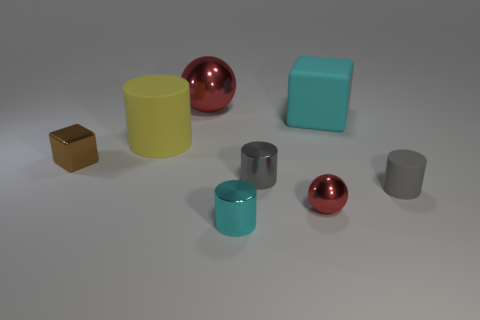Is the sphere in front of the yellow object made of the same material as the block right of the small brown block?
Make the answer very short. No. Are there an equal number of shiny spheres that are behind the tiny sphere and small matte things in front of the small cyan metallic thing?
Offer a terse response. No. How many large matte objects are the same color as the large rubber cylinder?
Your response must be concise. 0. What material is the sphere that is the same color as the large metallic object?
Provide a short and direct response. Metal. How many shiny things are either big yellow objects or tiny blocks?
Ensure brevity in your answer.  1. There is a tiny gray thing that is on the right side of the large matte cube; is its shape the same as the metallic thing behind the metallic block?
Offer a terse response. No. How many cylinders are in front of the brown metallic object?
Your answer should be compact. 3. Is there a small brown thing that has the same material as the cyan block?
Give a very brief answer. No. What is the material of the red object that is the same size as the cyan metallic object?
Provide a short and direct response. Metal. Is the yellow object made of the same material as the brown thing?
Offer a very short reply. No. 